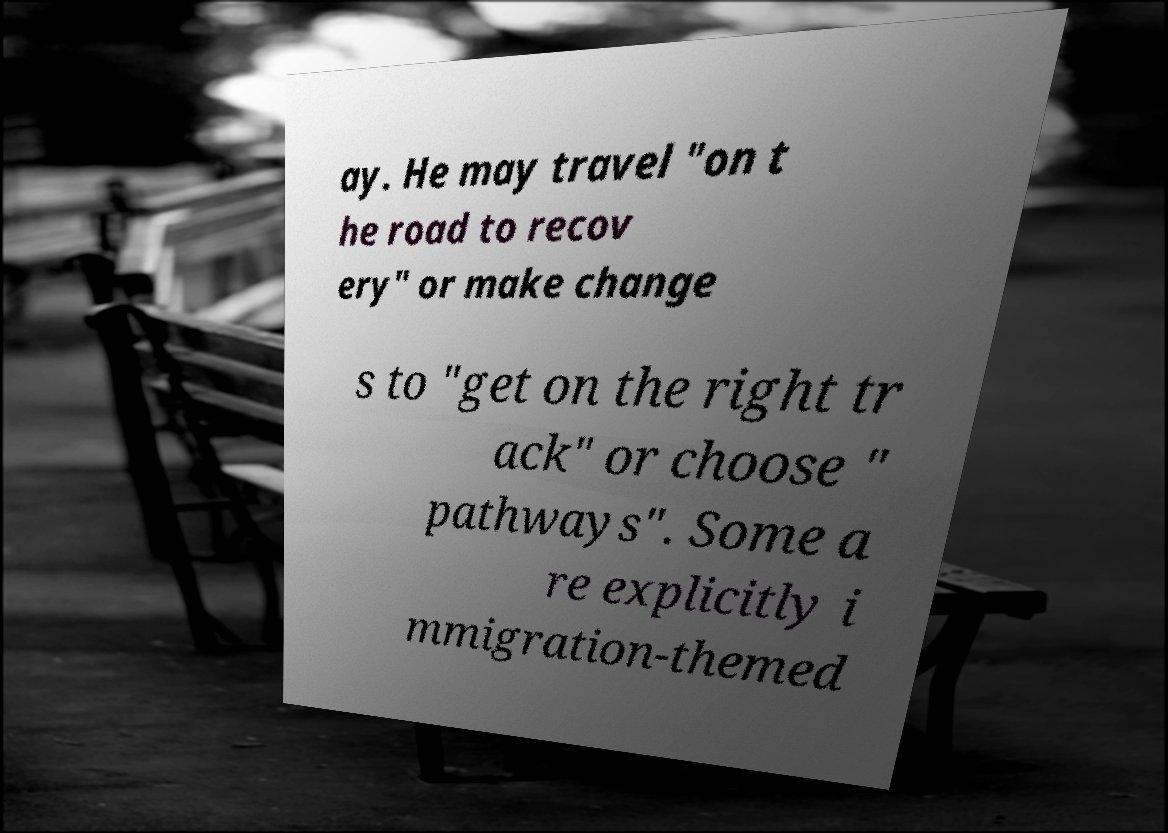Can you read and provide the text displayed in the image?This photo seems to have some interesting text. Can you extract and type it out for me? ay. He may travel "on t he road to recov ery" or make change s to "get on the right tr ack" or choose " pathways". Some a re explicitly i mmigration-themed 